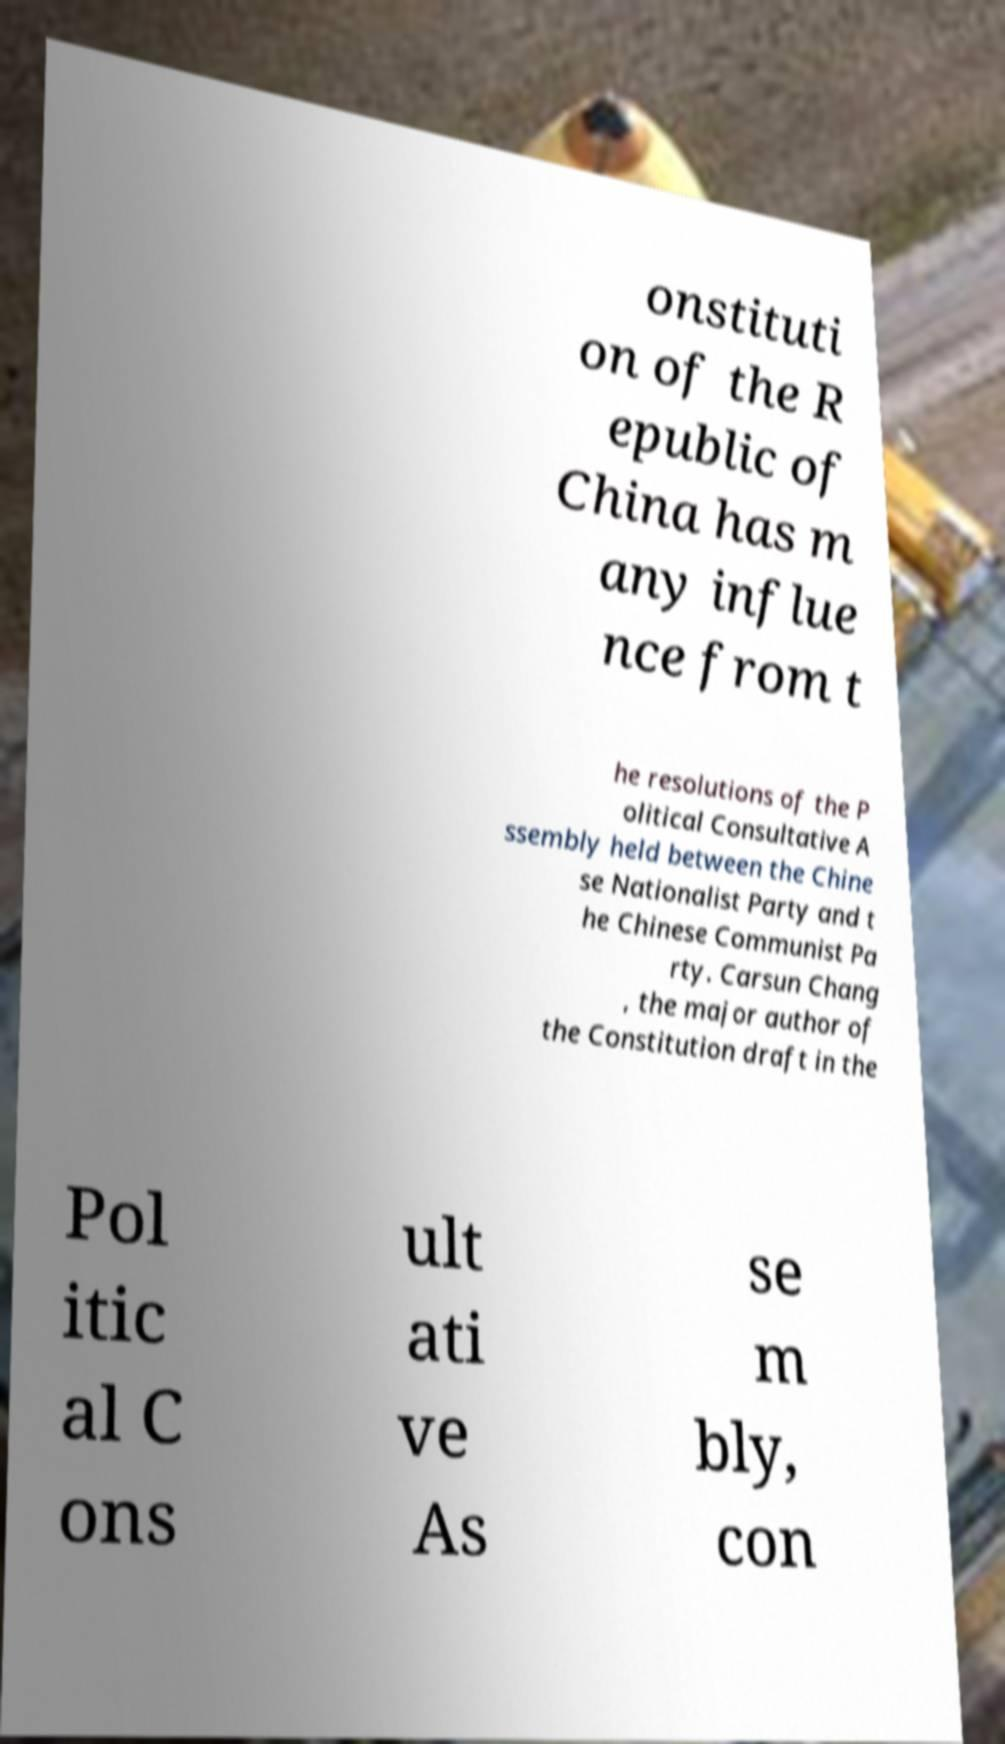What messages or text are displayed in this image? I need them in a readable, typed format. onstituti on of the R epublic of China has m any influe nce from t he resolutions of the P olitical Consultative A ssembly held between the Chine se Nationalist Party and t he Chinese Communist Pa rty. Carsun Chang , the major author of the Constitution draft in the Pol itic al C ons ult ati ve As se m bly, con 